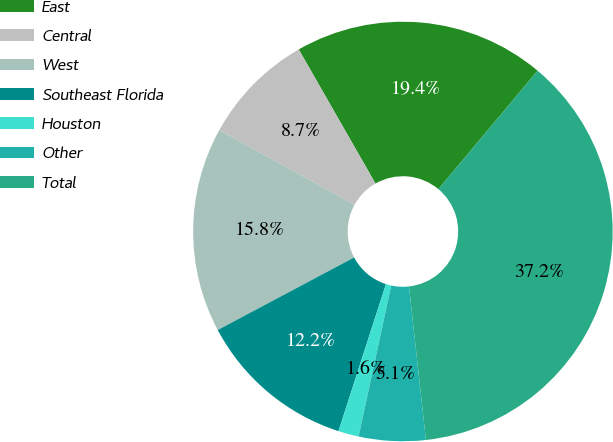Convert chart. <chart><loc_0><loc_0><loc_500><loc_500><pie_chart><fcel>East<fcel>Central<fcel>West<fcel>Southeast Florida<fcel>Houston<fcel>Other<fcel>Total<nl><fcel>19.37%<fcel>8.7%<fcel>15.81%<fcel>12.25%<fcel>1.58%<fcel>5.14%<fcel>37.15%<nl></chart> 